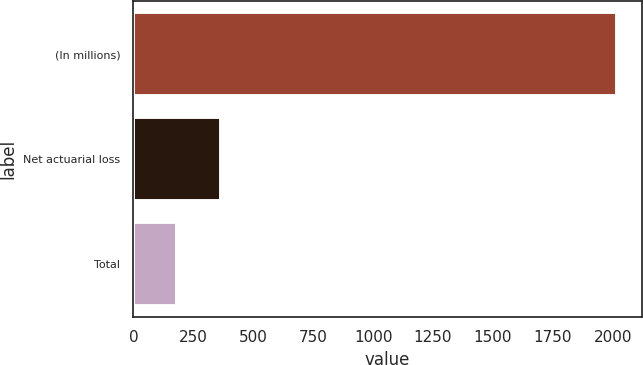Convert chart. <chart><loc_0><loc_0><loc_500><loc_500><bar_chart><fcel>(In millions)<fcel>Net actuarial loss<fcel>Total<nl><fcel>2019<fcel>365.7<fcel>182<nl></chart> 